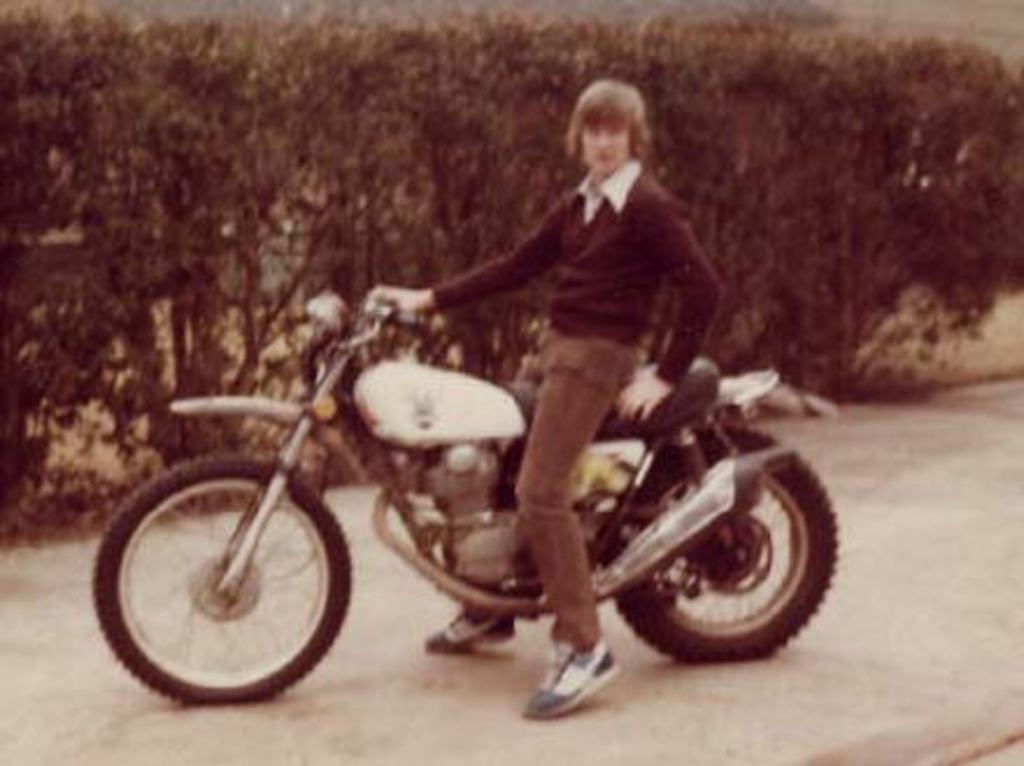Please provide a concise description of this image. In this picture we can see a man sitting on a motorbike and this bike is on the road and in the background we can see trees. 